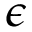<formula> <loc_0><loc_0><loc_500><loc_500>\epsilon</formula> 